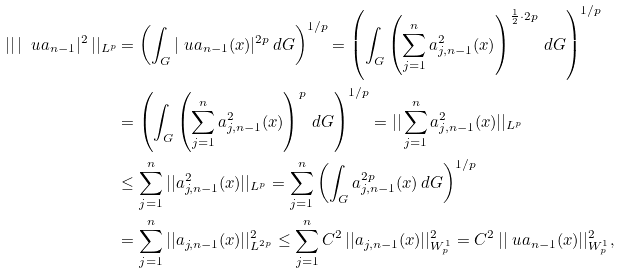Convert formula to latex. <formula><loc_0><loc_0><loc_500><loc_500>| | \, | \ u a _ { n - 1 } | ^ { 2 } \, | | _ { L ^ { p } } & = \left ( \int _ { G } | \ u a _ { n - 1 } ( x ) | ^ { 2 p } \, d G \right ) ^ { 1 / p } = \left ( \int _ { G } \left ( \sum _ { j = 1 } ^ { n } a _ { j , n - 1 } ^ { 2 } ( x ) \right ) ^ { \frac { 1 } { 2 } \cdot 2 p } \, d G \right ) ^ { 1 / p } \\ & = \left ( \int _ { G } \left ( \sum _ { j = 1 } ^ { n } a _ { j , n - 1 } ^ { 2 } ( x ) \right ) ^ { p } \, d G \right ) ^ { 1 / p } = | | \sum _ { j = 1 } ^ { n } a _ { j , n - 1 } ^ { 2 } ( x ) | | _ { L ^ { p } } \\ & \leq \sum _ { j = 1 } ^ { n } | | a ^ { 2 } _ { j , n - 1 } ( x ) | | _ { L ^ { p } } = \sum _ { j = 1 } ^ { n } \left ( \int _ { G } a _ { j , n - 1 } ^ { 2 p } ( x ) \, d G \right ) ^ { 1 / p } \\ & = \sum _ { j = 1 } ^ { n } | | a _ { j , n - 1 } ( x ) | | _ { L ^ { 2 p } } ^ { 2 } \leq \sum _ { j = 1 } ^ { n } C ^ { 2 } \, | | a _ { j , n - 1 } ( x ) | | _ { W _ { p } ^ { 1 } } ^ { 2 } = C ^ { 2 } \, | | \ u a _ { n - 1 } ( x ) | | _ { W _ { p } ^ { 1 } } ^ { 2 } ,</formula> 